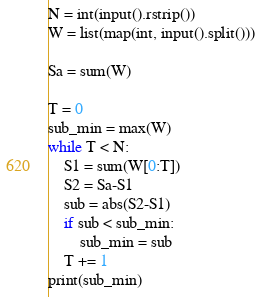Convert code to text. <code><loc_0><loc_0><loc_500><loc_500><_Python_>N = int(input().rstrip())
W = list(map(int, input().split()))

Sa = sum(W)

T = 0
sub_min = max(W)
while T < N:
    S1 = sum(W[0:T])
    S2 = Sa-S1
    sub = abs(S2-S1)
    if sub < sub_min:
        sub_min = sub
    T += 1    
print(sub_min)

</code> 